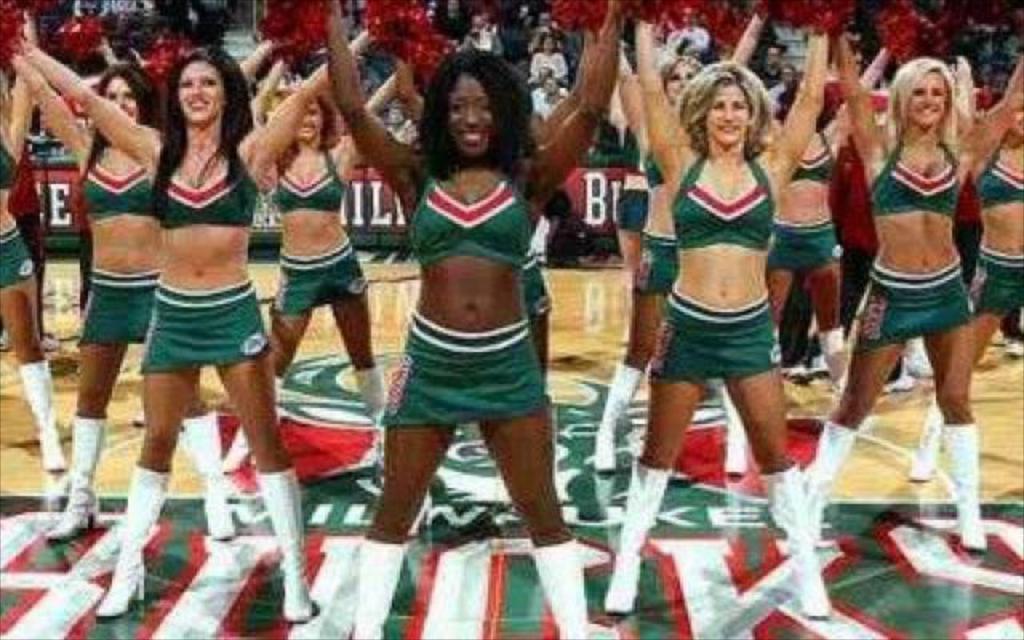Please provide a concise description of this image. In this image, there are a few people. Among them, some people holding some objects are standing. We can see the ground with some images and text. We can also see some boards with text. 